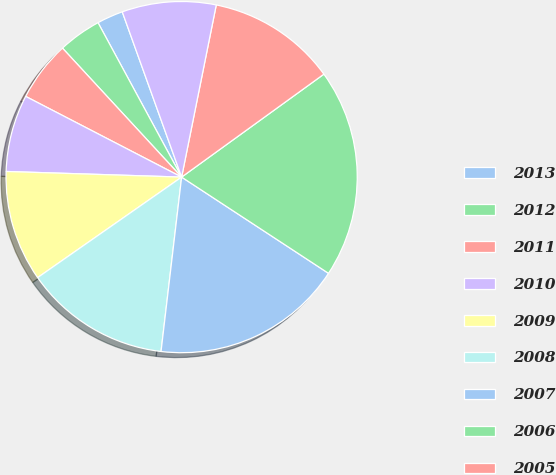<chart> <loc_0><loc_0><loc_500><loc_500><pie_chart><fcel>2013<fcel>2012<fcel>2011<fcel>2010<fcel>2009<fcel>2008<fcel>2007<fcel>2006<fcel>2005<fcel>2004<nl><fcel>2.41%<fcel>3.97%<fcel>5.53%<fcel>7.09%<fcel>10.21%<fcel>13.43%<fcel>17.64%<fcel>19.2%<fcel>11.87%<fcel>8.65%<nl></chart> 